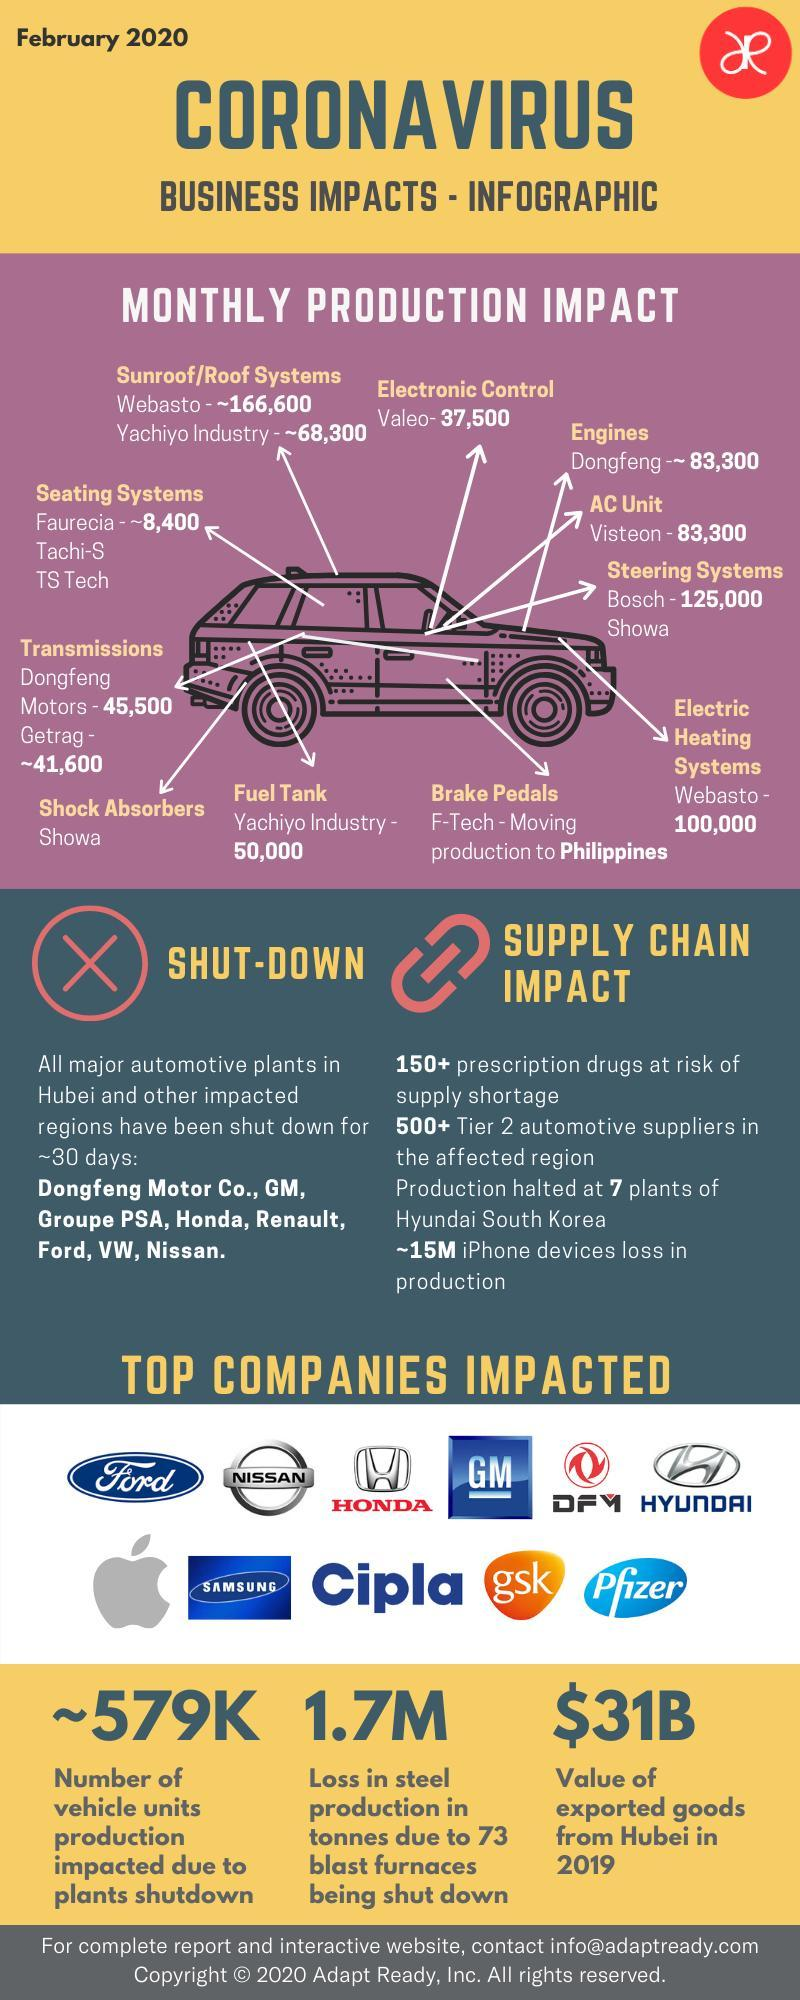How much is the value of exported goods from Hubei in 2019?
Answer the question with a short phrase. $31B What is the number of vehicle units production impacted due to the plants shutdown in February 2020? ~579K 